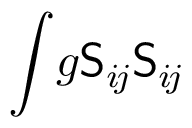Convert formula to latex. <formula><loc_0><loc_0><loc_500><loc_500>\int \, g S _ { i \, j } S _ { i \, j }</formula> 